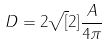<formula> <loc_0><loc_0><loc_500><loc_500>D = 2 \sqrt { [ } 2 ] { \frac { A } { 4 \pi } }</formula> 